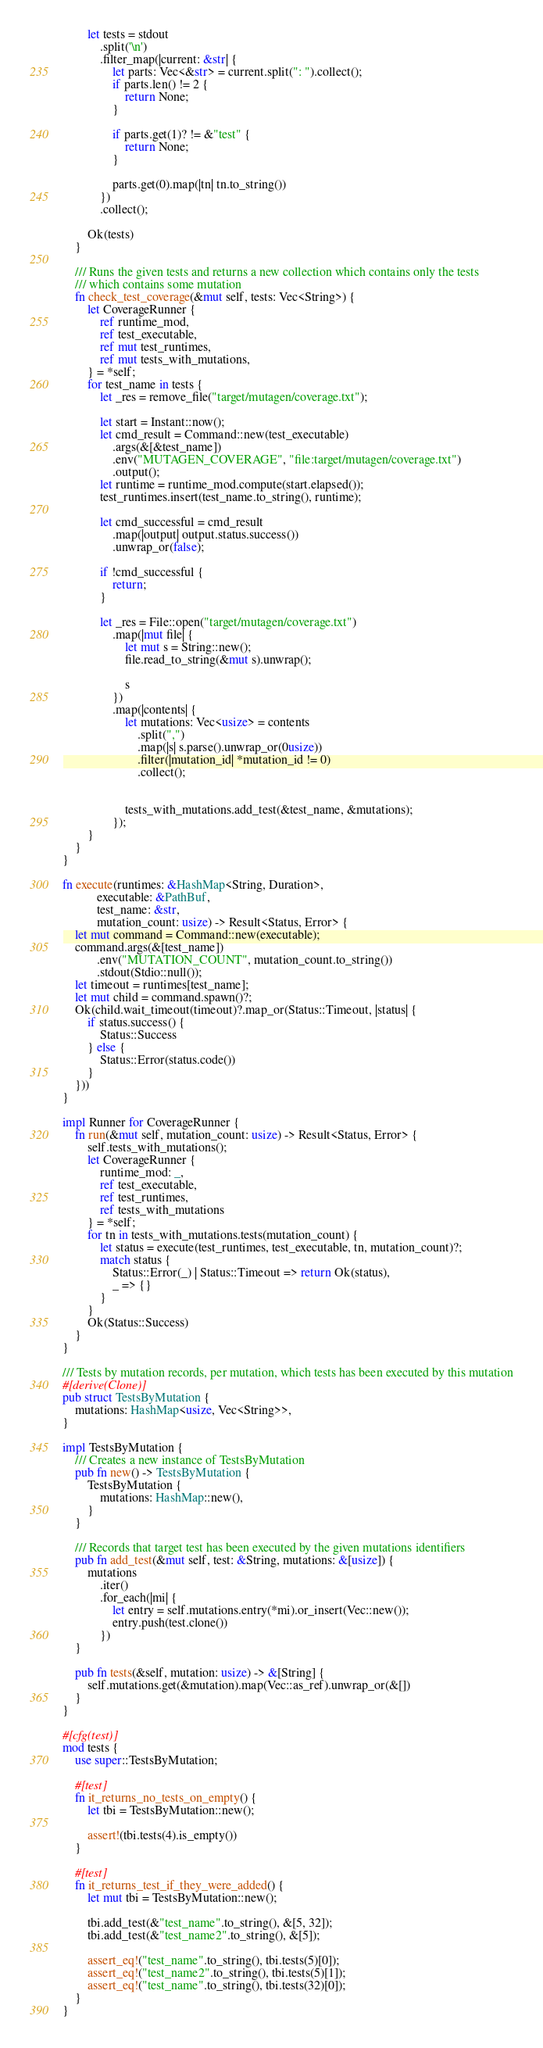<code> <loc_0><loc_0><loc_500><loc_500><_Rust_>        let tests = stdout
            .split('\n')
            .filter_map(|current: &str| {
                let parts: Vec<&str> = current.split(": ").collect();
                if parts.len() != 2 {
                    return None;
                }

                if parts.get(1)? != &"test" {
                    return None;
                }

                parts.get(0).map(|tn| tn.to_string())
            })
            .collect();

        Ok(tests)
    }

    /// Runs the given tests and returns a new collection which contains only the tests
    /// which contains some mutation
    fn check_test_coverage(&mut self, tests: Vec<String>) {
        let CoverageRunner {
            ref runtime_mod,
            ref test_executable,
            ref mut test_runtimes,
            ref mut tests_with_mutations,
        } = *self;
        for test_name in tests {
            let _res = remove_file("target/mutagen/coverage.txt");

            let start = Instant::now();
            let cmd_result = Command::new(test_executable)
                .args(&[&test_name])
                .env("MUTAGEN_COVERAGE", "file:target/mutagen/coverage.txt")
                .output();
            let runtime = runtime_mod.compute(start.elapsed());
            test_runtimes.insert(test_name.to_string(), runtime);

            let cmd_successful = cmd_result
                .map(|output| output.status.success())
                .unwrap_or(false);

            if !cmd_successful {
                return;
            }

            let _res = File::open("target/mutagen/coverage.txt")
                .map(|mut file| {
                    let mut s = String::new();
                    file.read_to_string(&mut s).unwrap();

                    s
                })
                .map(|contents| {
                    let mutations: Vec<usize> = contents
                        .split(",")
                        .map(|s| s.parse().unwrap_or(0usize))
                        .filter(|mutation_id| *mutation_id != 0)
                        .collect();


                    tests_with_mutations.add_test(&test_name, &mutations);
                });
        }
    }
}

fn execute(runtimes: &HashMap<String, Duration>,
           executable: &PathBuf,
           test_name: &str,
           mutation_count: usize) -> Result<Status, Error> {
    let mut command = Command::new(executable);
    command.args(&[test_name])
           .env("MUTATION_COUNT", mutation_count.to_string())
           .stdout(Stdio::null());
    let timeout = runtimes[test_name];
    let mut child = command.spawn()?;
    Ok(child.wait_timeout(timeout)?.map_or(Status::Timeout, |status| {
        if status.success() {
            Status::Success
        } else {
            Status::Error(status.code())
        }
    }))
}

impl Runner for CoverageRunner {
    fn run(&mut self, mutation_count: usize) -> Result<Status, Error> {
        self.tests_with_mutations();
        let CoverageRunner {
            runtime_mod: _,
            ref test_executable,
            ref test_runtimes,
            ref tests_with_mutations
        } = *self;
        for tn in tests_with_mutations.tests(mutation_count) {
            let status = execute(test_runtimes, test_executable, tn, mutation_count)?;
            match status {
                Status::Error(_) | Status::Timeout => return Ok(status),
                _ => {}
            }
        }
        Ok(Status::Success)
    }
}

/// Tests by mutation records, per mutation, which tests has been executed by this mutation
#[derive(Clone)]
pub struct TestsByMutation {
    mutations: HashMap<usize, Vec<String>>,
}

impl TestsByMutation {
    /// Creates a new instance of TestsByMutation
    pub fn new() -> TestsByMutation {
        TestsByMutation {
            mutations: HashMap::new(),
        }
    }

    /// Records that target test has been executed by the given mutations identifiers
    pub fn add_test(&mut self, test: &String, mutations: &[usize]) {
        mutations
            .iter()
            .for_each(|mi| {
                let entry = self.mutations.entry(*mi).or_insert(Vec::new());
                entry.push(test.clone())
            })
    }

    pub fn tests(&self, mutation: usize) -> &[String] {
        self.mutations.get(&mutation).map(Vec::as_ref).unwrap_or(&[])
    }
}

#[cfg(test)]
mod tests {
    use super::TestsByMutation;

    #[test]
    fn it_returns_no_tests_on_empty() {
        let tbi = TestsByMutation::new();

        assert!(tbi.tests(4).is_empty())
    }

    #[test]
    fn it_returns_test_if_they_were_added() {
        let mut tbi = TestsByMutation::new();

        tbi.add_test(&"test_name".to_string(), &[5, 32]);
        tbi.add_test(&"test_name2".to_string(), &[5]);

        assert_eq!("test_name".to_string(), tbi.tests(5)[0]);
        assert_eq!("test_name2".to_string(), tbi.tests(5)[1]);
        assert_eq!("test_name".to_string(), tbi.tests(32)[0]);
    }
}
</code> 